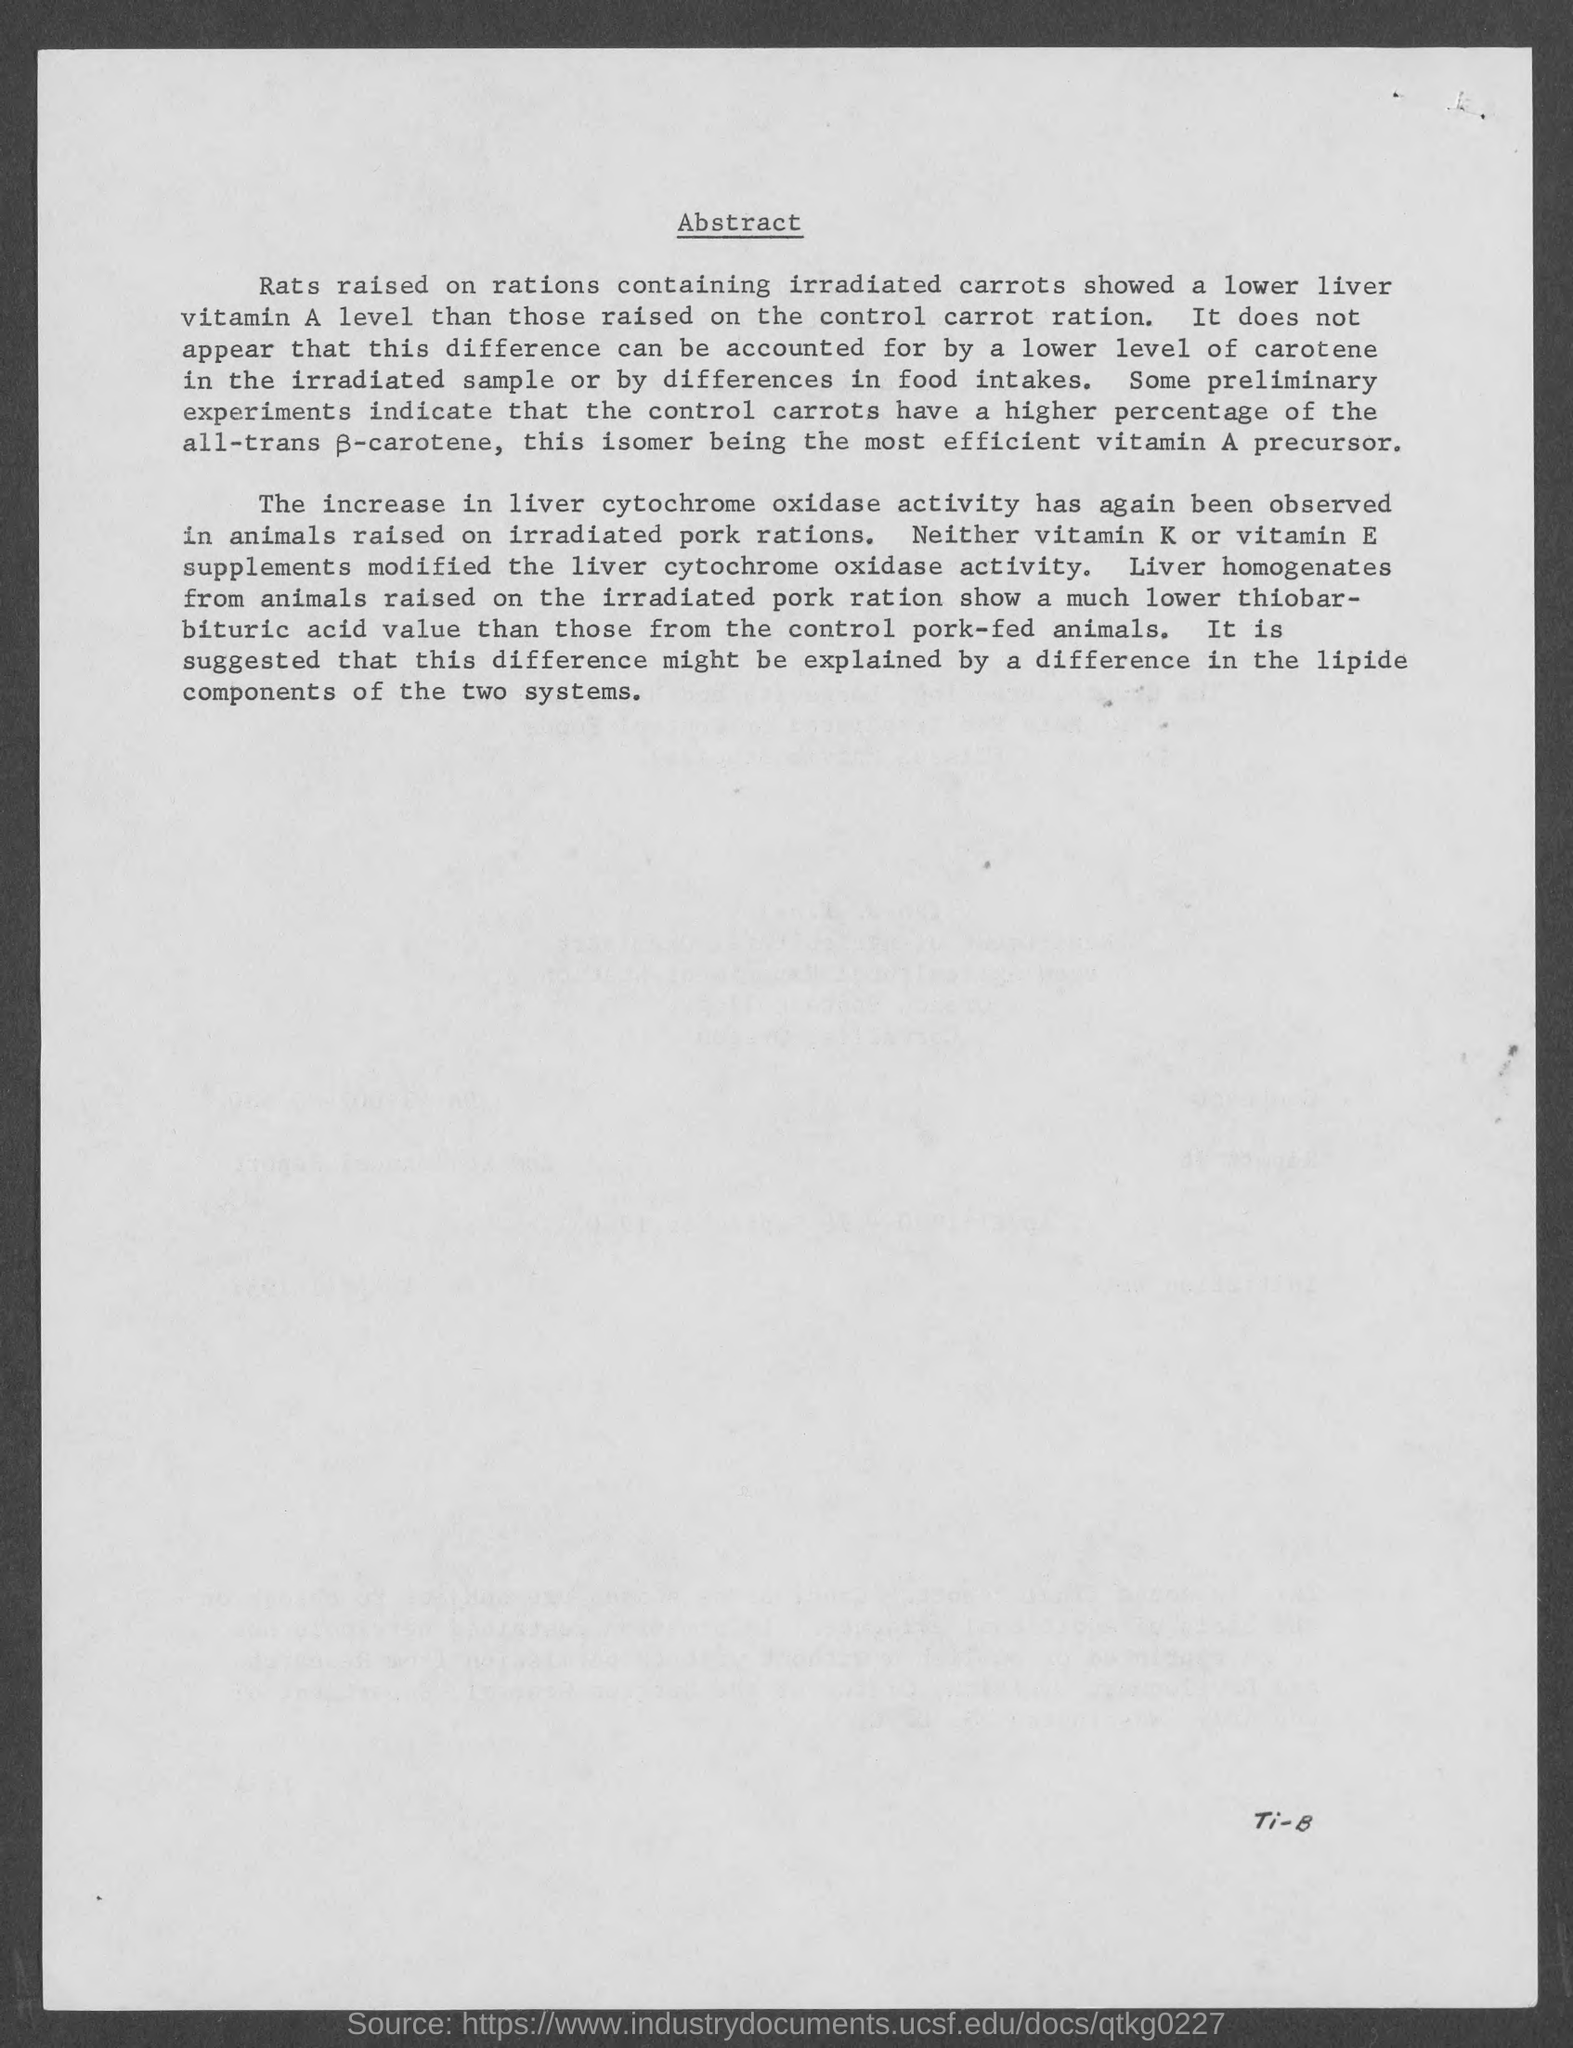What is the heading of the page ?
Offer a very short reply. Abstract. 